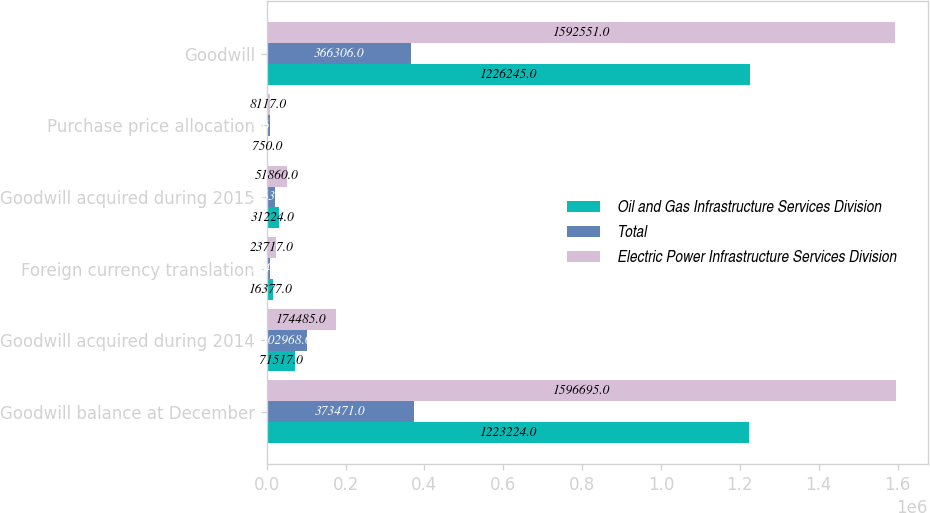Convert chart to OTSL. <chart><loc_0><loc_0><loc_500><loc_500><stacked_bar_chart><ecel><fcel>Goodwill balance at December<fcel>Goodwill acquired during 2014<fcel>Foreign currency translation<fcel>Goodwill acquired during 2015<fcel>Purchase price allocation<fcel>Goodwill<nl><fcel>Oil and Gas Infrastructure Services Division<fcel>1.22322e+06<fcel>71517<fcel>16377<fcel>31224<fcel>750<fcel>1.22624e+06<nl><fcel>Total<fcel>373471<fcel>102968<fcel>7340<fcel>20636<fcel>8867<fcel>366306<nl><fcel>Electric Power Infrastructure Services Division<fcel>1.5967e+06<fcel>174485<fcel>23717<fcel>51860<fcel>8117<fcel>1.59255e+06<nl></chart> 